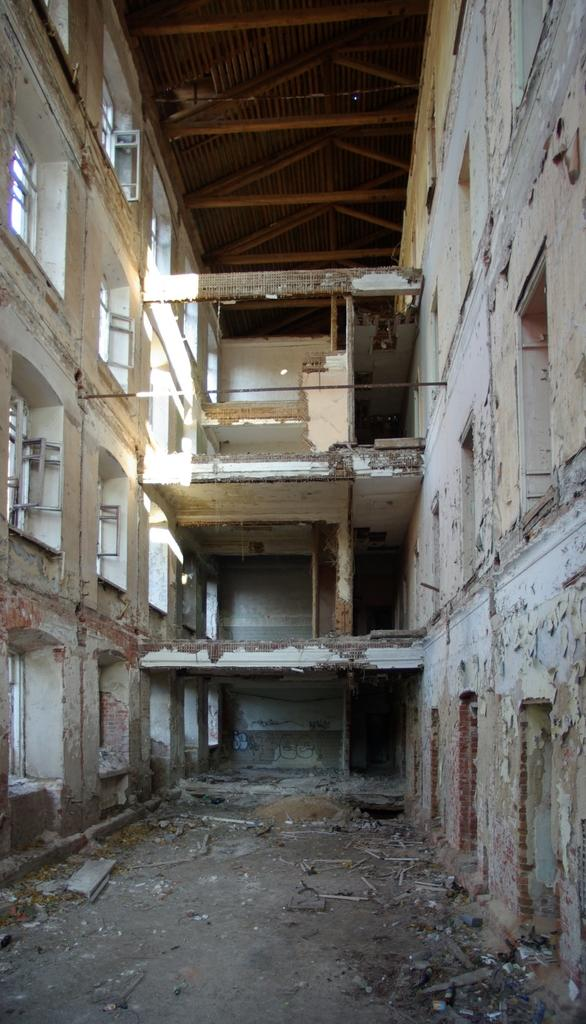What type of structure is present in the image? There is an abandoned building in the image. What feature can be seen on the walls of the building? The building has windows on its walls. What type of juice is being served in the abandoned building? There is no juice or any indication of a serving in the image; it only shows an abandoned building with windows. 